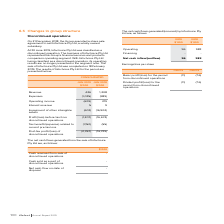According to Iselect's financial document, When was  Infochoice Pty Ltd classified as a discontinued operation? According to the financial document, 30 June 2019. The relevant text states: "At 30 June 2019, Infochoice Pty Ltd was classified as a discontinued operation. The business of Infochoice Pty Ltd..." Also, What did the business of Infochoice Pty Ltd represent? the Group’s financial services and products comparison operating segment. The document states: "n. The business of Infochoice Pty Ltd represented the Group’s financial services and products comparison operating segment. With Infochoice Pty Ltd be..." Also, What is the Post-tax loss of  discontinued operations in 2019? According to the financial document, 2,357 (in thousands). The relevant text states: "ost-tax profit/(loss) of discontinued operations (2,357) (16,729)..." Also, can you calculate: What is the percentage change in the revenue from 2018 to 2019? To answer this question, I need to perform calculations using the financial data. The calculation is: (426-1,208)/1,208, which equals -64.74 (percentage). This is based on the information: "Revenue 426 1,208 Revenue 426 1,208..." The key data points involved are: 1,208, 426. Also, can you calculate: What is the percentage change in the interest revenue from 2018 to 2019? To answer this question, I need to perform calculations using the financial data. The calculation is: (5-9)/9, which equals -44.44 (percentage). This is based on the information: "Expenses (1,035) (989) Expenses (1,035) (989)..." The key data points involved are: 5, 9. Additionally, In which year is there a higher revenue? According to the financial document, 2018. The relevant text states: "JUN 2019 $’000 JUN 2018 $’000..." 